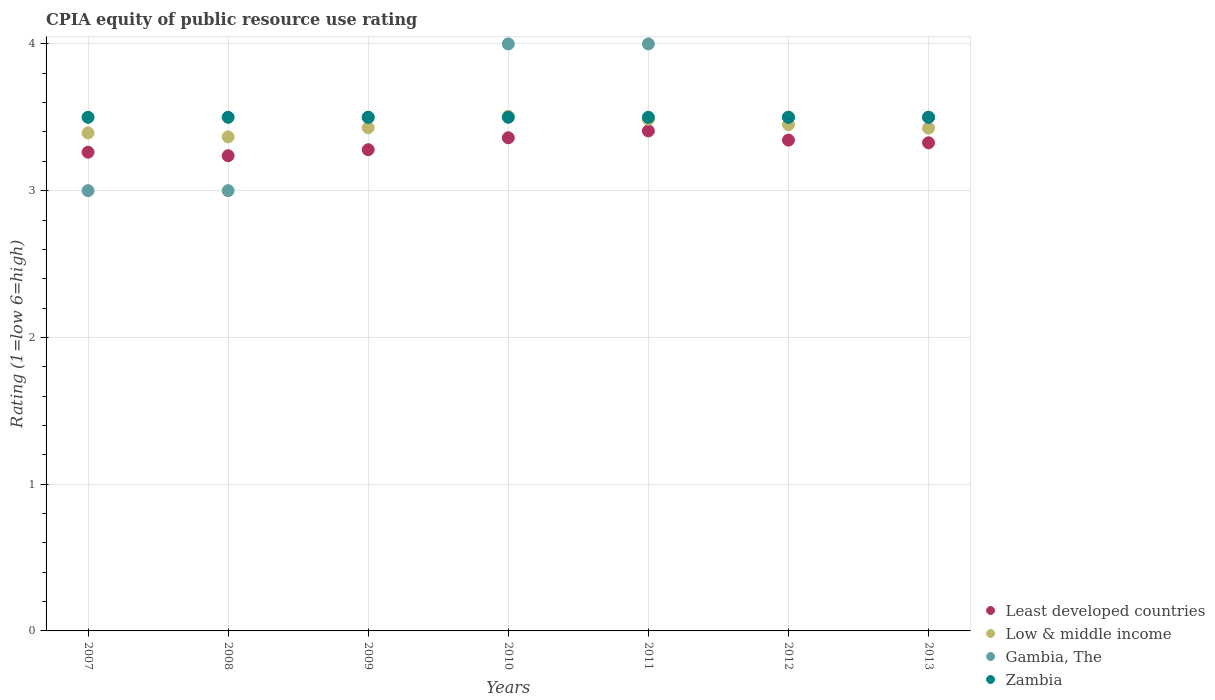How many different coloured dotlines are there?
Provide a short and direct response. 4. Across all years, what is the maximum CPIA rating in Zambia?
Offer a very short reply. 3.5. Across all years, what is the minimum CPIA rating in Zambia?
Make the answer very short. 3.5. What is the difference between the CPIA rating in Low & middle income in 2010 and that in 2012?
Your answer should be compact. 0.06. What is the difference between the CPIA rating in Zambia in 2013 and the CPIA rating in Low & middle income in 2012?
Provide a short and direct response. 0.05. What is the average CPIA rating in Least developed countries per year?
Make the answer very short. 3.32. In the year 2009, what is the difference between the CPIA rating in Zambia and CPIA rating in Low & middle income?
Your response must be concise. 0.07. In how many years, is the CPIA rating in Zambia greater than 1?
Ensure brevity in your answer.  7. What is the ratio of the CPIA rating in Zambia in 2008 to that in 2013?
Offer a terse response. 1. Is the CPIA rating in Least developed countries in 2010 less than that in 2011?
Give a very brief answer. Yes. What is the difference between the highest and the second highest CPIA rating in Low & middle income?
Your response must be concise. 0.02. In how many years, is the CPIA rating in Zambia greater than the average CPIA rating in Zambia taken over all years?
Provide a short and direct response. 0. Is the sum of the CPIA rating in Zambia in 2008 and 2011 greater than the maximum CPIA rating in Gambia, The across all years?
Give a very brief answer. Yes. Is it the case that in every year, the sum of the CPIA rating in Least developed countries and CPIA rating in Low & middle income  is greater than the sum of CPIA rating in Gambia, The and CPIA rating in Zambia?
Ensure brevity in your answer.  No. Is the CPIA rating in Low & middle income strictly greater than the CPIA rating in Least developed countries over the years?
Keep it short and to the point. Yes. How many dotlines are there?
Your answer should be compact. 4. What is the difference between two consecutive major ticks on the Y-axis?
Your response must be concise. 1. Are the values on the major ticks of Y-axis written in scientific E-notation?
Provide a succinct answer. No. Does the graph contain grids?
Offer a terse response. Yes. How many legend labels are there?
Give a very brief answer. 4. How are the legend labels stacked?
Make the answer very short. Vertical. What is the title of the graph?
Make the answer very short. CPIA equity of public resource use rating. What is the label or title of the X-axis?
Provide a succinct answer. Years. What is the Rating (1=low 6=high) in Least developed countries in 2007?
Provide a short and direct response. 3.26. What is the Rating (1=low 6=high) of Low & middle income in 2007?
Your response must be concise. 3.39. What is the Rating (1=low 6=high) of Gambia, The in 2007?
Keep it short and to the point. 3. What is the Rating (1=low 6=high) in Least developed countries in 2008?
Your answer should be compact. 3.24. What is the Rating (1=low 6=high) in Low & middle income in 2008?
Give a very brief answer. 3.37. What is the Rating (1=low 6=high) of Gambia, The in 2008?
Your answer should be very brief. 3. What is the Rating (1=low 6=high) of Zambia in 2008?
Offer a very short reply. 3.5. What is the Rating (1=low 6=high) in Least developed countries in 2009?
Your response must be concise. 3.28. What is the Rating (1=low 6=high) of Low & middle income in 2009?
Your response must be concise. 3.43. What is the Rating (1=low 6=high) in Least developed countries in 2010?
Provide a succinct answer. 3.36. What is the Rating (1=low 6=high) of Low & middle income in 2010?
Offer a terse response. 3.51. What is the Rating (1=low 6=high) of Gambia, The in 2010?
Make the answer very short. 4. What is the Rating (1=low 6=high) of Zambia in 2010?
Ensure brevity in your answer.  3.5. What is the Rating (1=low 6=high) in Least developed countries in 2011?
Offer a terse response. 3.41. What is the Rating (1=low 6=high) of Low & middle income in 2011?
Make the answer very short. 3.49. What is the Rating (1=low 6=high) of Zambia in 2011?
Provide a short and direct response. 3.5. What is the Rating (1=low 6=high) in Least developed countries in 2012?
Offer a terse response. 3.34. What is the Rating (1=low 6=high) of Low & middle income in 2012?
Offer a very short reply. 3.45. What is the Rating (1=low 6=high) of Gambia, The in 2012?
Make the answer very short. 3.5. What is the Rating (1=low 6=high) of Least developed countries in 2013?
Your answer should be compact. 3.33. What is the Rating (1=low 6=high) of Low & middle income in 2013?
Provide a short and direct response. 3.43. Across all years, what is the maximum Rating (1=low 6=high) in Least developed countries?
Provide a short and direct response. 3.41. Across all years, what is the maximum Rating (1=low 6=high) in Low & middle income?
Your answer should be very brief. 3.51. Across all years, what is the maximum Rating (1=low 6=high) in Gambia, The?
Offer a very short reply. 4. Across all years, what is the maximum Rating (1=low 6=high) of Zambia?
Your answer should be compact. 3.5. Across all years, what is the minimum Rating (1=low 6=high) of Least developed countries?
Keep it short and to the point. 3.24. Across all years, what is the minimum Rating (1=low 6=high) of Low & middle income?
Keep it short and to the point. 3.37. Across all years, what is the minimum Rating (1=low 6=high) of Gambia, The?
Make the answer very short. 3. Across all years, what is the minimum Rating (1=low 6=high) in Zambia?
Give a very brief answer. 3.5. What is the total Rating (1=low 6=high) of Least developed countries in the graph?
Ensure brevity in your answer.  23.22. What is the total Rating (1=low 6=high) of Low & middle income in the graph?
Offer a very short reply. 24.06. What is the total Rating (1=low 6=high) of Zambia in the graph?
Offer a terse response. 24.5. What is the difference between the Rating (1=low 6=high) of Least developed countries in 2007 and that in 2008?
Keep it short and to the point. 0.02. What is the difference between the Rating (1=low 6=high) of Low & middle income in 2007 and that in 2008?
Your response must be concise. 0.03. What is the difference between the Rating (1=low 6=high) in Gambia, The in 2007 and that in 2008?
Provide a succinct answer. 0. What is the difference between the Rating (1=low 6=high) of Zambia in 2007 and that in 2008?
Provide a succinct answer. 0. What is the difference between the Rating (1=low 6=high) in Least developed countries in 2007 and that in 2009?
Provide a succinct answer. -0.02. What is the difference between the Rating (1=low 6=high) in Low & middle income in 2007 and that in 2009?
Offer a very short reply. -0.04. What is the difference between the Rating (1=low 6=high) of Least developed countries in 2007 and that in 2010?
Offer a terse response. -0.1. What is the difference between the Rating (1=low 6=high) in Low & middle income in 2007 and that in 2010?
Give a very brief answer. -0.11. What is the difference between the Rating (1=low 6=high) of Least developed countries in 2007 and that in 2011?
Your response must be concise. -0.15. What is the difference between the Rating (1=low 6=high) of Low & middle income in 2007 and that in 2011?
Ensure brevity in your answer.  -0.09. What is the difference between the Rating (1=low 6=high) in Zambia in 2007 and that in 2011?
Provide a short and direct response. 0. What is the difference between the Rating (1=low 6=high) in Least developed countries in 2007 and that in 2012?
Ensure brevity in your answer.  -0.08. What is the difference between the Rating (1=low 6=high) of Low & middle income in 2007 and that in 2012?
Make the answer very short. -0.06. What is the difference between the Rating (1=low 6=high) of Gambia, The in 2007 and that in 2012?
Your response must be concise. -0.5. What is the difference between the Rating (1=low 6=high) in Zambia in 2007 and that in 2012?
Provide a succinct answer. 0. What is the difference between the Rating (1=low 6=high) of Least developed countries in 2007 and that in 2013?
Provide a short and direct response. -0.06. What is the difference between the Rating (1=low 6=high) in Low & middle income in 2007 and that in 2013?
Ensure brevity in your answer.  -0.03. What is the difference between the Rating (1=low 6=high) in Gambia, The in 2007 and that in 2013?
Keep it short and to the point. -0.5. What is the difference between the Rating (1=low 6=high) of Zambia in 2007 and that in 2013?
Give a very brief answer. 0. What is the difference between the Rating (1=low 6=high) in Least developed countries in 2008 and that in 2009?
Provide a short and direct response. -0.04. What is the difference between the Rating (1=low 6=high) in Low & middle income in 2008 and that in 2009?
Offer a very short reply. -0.06. What is the difference between the Rating (1=low 6=high) in Gambia, The in 2008 and that in 2009?
Give a very brief answer. -0.5. What is the difference between the Rating (1=low 6=high) of Least developed countries in 2008 and that in 2010?
Your answer should be compact. -0.12. What is the difference between the Rating (1=low 6=high) of Low & middle income in 2008 and that in 2010?
Give a very brief answer. -0.14. What is the difference between the Rating (1=low 6=high) in Least developed countries in 2008 and that in 2011?
Your response must be concise. -0.17. What is the difference between the Rating (1=low 6=high) in Low & middle income in 2008 and that in 2011?
Your response must be concise. -0.12. What is the difference between the Rating (1=low 6=high) of Gambia, The in 2008 and that in 2011?
Keep it short and to the point. -1. What is the difference between the Rating (1=low 6=high) in Least developed countries in 2008 and that in 2012?
Give a very brief answer. -0.11. What is the difference between the Rating (1=low 6=high) of Low & middle income in 2008 and that in 2012?
Provide a short and direct response. -0.08. What is the difference between the Rating (1=low 6=high) in Least developed countries in 2008 and that in 2013?
Offer a terse response. -0.09. What is the difference between the Rating (1=low 6=high) in Low & middle income in 2008 and that in 2013?
Your answer should be compact. -0.06. What is the difference between the Rating (1=low 6=high) of Least developed countries in 2009 and that in 2010?
Keep it short and to the point. -0.08. What is the difference between the Rating (1=low 6=high) in Low & middle income in 2009 and that in 2010?
Provide a short and direct response. -0.08. What is the difference between the Rating (1=low 6=high) in Gambia, The in 2009 and that in 2010?
Your response must be concise. -0.5. What is the difference between the Rating (1=low 6=high) in Zambia in 2009 and that in 2010?
Give a very brief answer. 0. What is the difference between the Rating (1=low 6=high) in Least developed countries in 2009 and that in 2011?
Your answer should be compact. -0.13. What is the difference between the Rating (1=low 6=high) in Low & middle income in 2009 and that in 2011?
Your answer should be compact. -0.06. What is the difference between the Rating (1=low 6=high) in Gambia, The in 2009 and that in 2011?
Your answer should be very brief. -0.5. What is the difference between the Rating (1=low 6=high) in Zambia in 2009 and that in 2011?
Offer a very short reply. 0. What is the difference between the Rating (1=low 6=high) of Least developed countries in 2009 and that in 2012?
Provide a succinct answer. -0.07. What is the difference between the Rating (1=low 6=high) of Low & middle income in 2009 and that in 2012?
Provide a succinct answer. -0.02. What is the difference between the Rating (1=low 6=high) in Least developed countries in 2009 and that in 2013?
Your response must be concise. -0.05. What is the difference between the Rating (1=low 6=high) of Low & middle income in 2009 and that in 2013?
Your response must be concise. 0. What is the difference between the Rating (1=low 6=high) of Least developed countries in 2010 and that in 2011?
Keep it short and to the point. -0.05. What is the difference between the Rating (1=low 6=high) of Low & middle income in 2010 and that in 2011?
Offer a terse response. 0.02. What is the difference between the Rating (1=low 6=high) in Least developed countries in 2010 and that in 2012?
Offer a terse response. 0.02. What is the difference between the Rating (1=low 6=high) of Low & middle income in 2010 and that in 2012?
Your response must be concise. 0.06. What is the difference between the Rating (1=low 6=high) of Zambia in 2010 and that in 2012?
Ensure brevity in your answer.  0. What is the difference between the Rating (1=low 6=high) of Least developed countries in 2010 and that in 2013?
Your response must be concise. 0.03. What is the difference between the Rating (1=low 6=high) of Low & middle income in 2010 and that in 2013?
Ensure brevity in your answer.  0.08. What is the difference between the Rating (1=low 6=high) in Least developed countries in 2011 and that in 2012?
Offer a terse response. 0.06. What is the difference between the Rating (1=low 6=high) of Low & middle income in 2011 and that in 2012?
Keep it short and to the point. 0.04. What is the difference between the Rating (1=low 6=high) of Zambia in 2011 and that in 2012?
Your answer should be compact. 0. What is the difference between the Rating (1=low 6=high) in Least developed countries in 2011 and that in 2013?
Your answer should be compact. 0.08. What is the difference between the Rating (1=low 6=high) in Low & middle income in 2011 and that in 2013?
Provide a short and direct response. 0.06. What is the difference between the Rating (1=low 6=high) of Gambia, The in 2011 and that in 2013?
Your answer should be very brief. 0.5. What is the difference between the Rating (1=low 6=high) in Zambia in 2011 and that in 2013?
Offer a terse response. 0. What is the difference between the Rating (1=low 6=high) of Least developed countries in 2012 and that in 2013?
Provide a succinct answer. 0.02. What is the difference between the Rating (1=low 6=high) in Low & middle income in 2012 and that in 2013?
Offer a terse response. 0.02. What is the difference between the Rating (1=low 6=high) of Zambia in 2012 and that in 2013?
Make the answer very short. 0. What is the difference between the Rating (1=low 6=high) of Least developed countries in 2007 and the Rating (1=low 6=high) of Low & middle income in 2008?
Provide a succinct answer. -0.1. What is the difference between the Rating (1=low 6=high) in Least developed countries in 2007 and the Rating (1=low 6=high) in Gambia, The in 2008?
Make the answer very short. 0.26. What is the difference between the Rating (1=low 6=high) of Least developed countries in 2007 and the Rating (1=low 6=high) of Zambia in 2008?
Provide a succinct answer. -0.24. What is the difference between the Rating (1=low 6=high) of Low & middle income in 2007 and the Rating (1=low 6=high) of Gambia, The in 2008?
Keep it short and to the point. 0.39. What is the difference between the Rating (1=low 6=high) of Low & middle income in 2007 and the Rating (1=low 6=high) of Zambia in 2008?
Make the answer very short. -0.11. What is the difference between the Rating (1=low 6=high) in Gambia, The in 2007 and the Rating (1=low 6=high) in Zambia in 2008?
Provide a short and direct response. -0.5. What is the difference between the Rating (1=low 6=high) in Least developed countries in 2007 and the Rating (1=low 6=high) in Low & middle income in 2009?
Your response must be concise. -0.17. What is the difference between the Rating (1=low 6=high) of Least developed countries in 2007 and the Rating (1=low 6=high) of Gambia, The in 2009?
Ensure brevity in your answer.  -0.24. What is the difference between the Rating (1=low 6=high) in Least developed countries in 2007 and the Rating (1=low 6=high) in Zambia in 2009?
Keep it short and to the point. -0.24. What is the difference between the Rating (1=low 6=high) in Low & middle income in 2007 and the Rating (1=low 6=high) in Gambia, The in 2009?
Ensure brevity in your answer.  -0.11. What is the difference between the Rating (1=low 6=high) in Low & middle income in 2007 and the Rating (1=low 6=high) in Zambia in 2009?
Keep it short and to the point. -0.11. What is the difference between the Rating (1=low 6=high) of Least developed countries in 2007 and the Rating (1=low 6=high) of Low & middle income in 2010?
Keep it short and to the point. -0.24. What is the difference between the Rating (1=low 6=high) in Least developed countries in 2007 and the Rating (1=low 6=high) in Gambia, The in 2010?
Offer a terse response. -0.74. What is the difference between the Rating (1=low 6=high) in Least developed countries in 2007 and the Rating (1=low 6=high) in Zambia in 2010?
Your response must be concise. -0.24. What is the difference between the Rating (1=low 6=high) in Low & middle income in 2007 and the Rating (1=low 6=high) in Gambia, The in 2010?
Your response must be concise. -0.61. What is the difference between the Rating (1=low 6=high) of Low & middle income in 2007 and the Rating (1=low 6=high) of Zambia in 2010?
Keep it short and to the point. -0.11. What is the difference between the Rating (1=low 6=high) in Gambia, The in 2007 and the Rating (1=low 6=high) in Zambia in 2010?
Make the answer very short. -0.5. What is the difference between the Rating (1=low 6=high) in Least developed countries in 2007 and the Rating (1=low 6=high) in Low & middle income in 2011?
Provide a succinct answer. -0.23. What is the difference between the Rating (1=low 6=high) in Least developed countries in 2007 and the Rating (1=low 6=high) in Gambia, The in 2011?
Make the answer very short. -0.74. What is the difference between the Rating (1=low 6=high) in Least developed countries in 2007 and the Rating (1=low 6=high) in Zambia in 2011?
Keep it short and to the point. -0.24. What is the difference between the Rating (1=low 6=high) in Low & middle income in 2007 and the Rating (1=low 6=high) in Gambia, The in 2011?
Give a very brief answer. -0.61. What is the difference between the Rating (1=low 6=high) of Low & middle income in 2007 and the Rating (1=low 6=high) of Zambia in 2011?
Your answer should be compact. -0.11. What is the difference between the Rating (1=low 6=high) of Least developed countries in 2007 and the Rating (1=low 6=high) of Low & middle income in 2012?
Your answer should be compact. -0.19. What is the difference between the Rating (1=low 6=high) of Least developed countries in 2007 and the Rating (1=low 6=high) of Gambia, The in 2012?
Ensure brevity in your answer.  -0.24. What is the difference between the Rating (1=low 6=high) in Least developed countries in 2007 and the Rating (1=low 6=high) in Zambia in 2012?
Ensure brevity in your answer.  -0.24. What is the difference between the Rating (1=low 6=high) of Low & middle income in 2007 and the Rating (1=low 6=high) of Gambia, The in 2012?
Ensure brevity in your answer.  -0.11. What is the difference between the Rating (1=low 6=high) of Low & middle income in 2007 and the Rating (1=low 6=high) of Zambia in 2012?
Ensure brevity in your answer.  -0.11. What is the difference between the Rating (1=low 6=high) of Gambia, The in 2007 and the Rating (1=low 6=high) of Zambia in 2012?
Your answer should be very brief. -0.5. What is the difference between the Rating (1=low 6=high) in Least developed countries in 2007 and the Rating (1=low 6=high) in Low & middle income in 2013?
Keep it short and to the point. -0.16. What is the difference between the Rating (1=low 6=high) of Least developed countries in 2007 and the Rating (1=low 6=high) of Gambia, The in 2013?
Your answer should be compact. -0.24. What is the difference between the Rating (1=low 6=high) in Least developed countries in 2007 and the Rating (1=low 6=high) in Zambia in 2013?
Your answer should be very brief. -0.24. What is the difference between the Rating (1=low 6=high) in Low & middle income in 2007 and the Rating (1=low 6=high) in Gambia, The in 2013?
Ensure brevity in your answer.  -0.11. What is the difference between the Rating (1=low 6=high) of Low & middle income in 2007 and the Rating (1=low 6=high) of Zambia in 2013?
Ensure brevity in your answer.  -0.11. What is the difference between the Rating (1=low 6=high) of Gambia, The in 2007 and the Rating (1=low 6=high) of Zambia in 2013?
Ensure brevity in your answer.  -0.5. What is the difference between the Rating (1=low 6=high) of Least developed countries in 2008 and the Rating (1=low 6=high) of Low & middle income in 2009?
Your answer should be compact. -0.19. What is the difference between the Rating (1=low 6=high) of Least developed countries in 2008 and the Rating (1=low 6=high) of Gambia, The in 2009?
Your response must be concise. -0.26. What is the difference between the Rating (1=low 6=high) in Least developed countries in 2008 and the Rating (1=low 6=high) in Zambia in 2009?
Your response must be concise. -0.26. What is the difference between the Rating (1=low 6=high) in Low & middle income in 2008 and the Rating (1=low 6=high) in Gambia, The in 2009?
Ensure brevity in your answer.  -0.13. What is the difference between the Rating (1=low 6=high) of Low & middle income in 2008 and the Rating (1=low 6=high) of Zambia in 2009?
Give a very brief answer. -0.13. What is the difference between the Rating (1=low 6=high) in Least developed countries in 2008 and the Rating (1=low 6=high) in Low & middle income in 2010?
Your answer should be compact. -0.27. What is the difference between the Rating (1=low 6=high) of Least developed countries in 2008 and the Rating (1=low 6=high) of Gambia, The in 2010?
Offer a terse response. -0.76. What is the difference between the Rating (1=low 6=high) of Least developed countries in 2008 and the Rating (1=low 6=high) of Zambia in 2010?
Keep it short and to the point. -0.26. What is the difference between the Rating (1=low 6=high) of Low & middle income in 2008 and the Rating (1=low 6=high) of Gambia, The in 2010?
Ensure brevity in your answer.  -0.63. What is the difference between the Rating (1=low 6=high) in Low & middle income in 2008 and the Rating (1=low 6=high) in Zambia in 2010?
Your answer should be compact. -0.13. What is the difference between the Rating (1=low 6=high) of Least developed countries in 2008 and the Rating (1=low 6=high) of Low & middle income in 2011?
Provide a short and direct response. -0.25. What is the difference between the Rating (1=low 6=high) in Least developed countries in 2008 and the Rating (1=low 6=high) in Gambia, The in 2011?
Provide a short and direct response. -0.76. What is the difference between the Rating (1=low 6=high) of Least developed countries in 2008 and the Rating (1=low 6=high) of Zambia in 2011?
Keep it short and to the point. -0.26. What is the difference between the Rating (1=low 6=high) in Low & middle income in 2008 and the Rating (1=low 6=high) in Gambia, The in 2011?
Give a very brief answer. -0.63. What is the difference between the Rating (1=low 6=high) of Low & middle income in 2008 and the Rating (1=low 6=high) of Zambia in 2011?
Provide a short and direct response. -0.13. What is the difference between the Rating (1=low 6=high) in Gambia, The in 2008 and the Rating (1=low 6=high) in Zambia in 2011?
Your response must be concise. -0.5. What is the difference between the Rating (1=low 6=high) in Least developed countries in 2008 and the Rating (1=low 6=high) in Low & middle income in 2012?
Provide a succinct answer. -0.21. What is the difference between the Rating (1=low 6=high) of Least developed countries in 2008 and the Rating (1=low 6=high) of Gambia, The in 2012?
Offer a terse response. -0.26. What is the difference between the Rating (1=low 6=high) in Least developed countries in 2008 and the Rating (1=low 6=high) in Zambia in 2012?
Provide a short and direct response. -0.26. What is the difference between the Rating (1=low 6=high) in Low & middle income in 2008 and the Rating (1=low 6=high) in Gambia, The in 2012?
Provide a short and direct response. -0.13. What is the difference between the Rating (1=low 6=high) of Low & middle income in 2008 and the Rating (1=low 6=high) of Zambia in 2012?
Your response must be concise. -0.13. What is the difference between the Rating (1=low 6=high) in Least developed countries in 2008 and the Rating (1=low 6=high) in Low & middle income in 2013?
Provide a succinct answer. -0.19. What is the difference between the Rating (1=low 6=high) of Least developed countries in 2008 and the Rating (1=low 6=high) of Gambia, The in 2013?
Your answer should be very brief. -0.26. What is the difference between the Rating (1=low 6=high) in Least developed countries in 2008 and the Rating (1=low 6=high) in Zambia in 2013?
Ensure brevity in your answer.  -0.26. What is the difference between the Rating (1=low 6=high) of Low & middle income in 2008 and the Rating (1=low 6=high) of Gambia, The in 2013?
Ensure brevity in your answer.  -0.13. What is the difference between the Rating (1=low 6=high) in Low & middle income in 2008 and the Rating (1=low 6=high) in Zambia in 2013?
Offer a very short reply. -0.13. What is the difference between the Rating (1=low 6=high) in Gambia, The in 2008 and the Rating (1=low 6=high) in Zambia in 2013?
Your answer should be compact. -0.5. What is the difference between the Rating (1=low 6=high) of Least developed countries in 2009 and the Rating (1=low 6=high) of Low & middle income in 2010?
Keep it short and to the point. -0.23. What is the difference between the Rating (1=low 6=high) of Least developed countries in 2009 and the Rating (1=low 6=high) of Gambia, The in 2010?
Make the answer very short. -0.72. What is the difference between the Rating (1=low 6=high) of Least developed countries in 2009 and the Rating (1=low 6=high) of Zambia in 2010?
Make the answer very short. -0.22. What is the difference between the Rating (1=low 6=high) in Low & middle income in 2009 and the Rating (1=low 6=high) in Gambia, The in 2010?
Provide a succinct answer. -0.57. What is the difference between the Rating (1=low 6=high) in Low & middle income in 2009 and the Rating (1=low 6=high) in Zambia in 2010?
Provide a succinct answer. -0.07. What is the difference between the Rating (1=low 6=high) in Least developed countries in 2009 and the Rating (1=low 6=high) in Low & middle income in 2011?
Keep it short and to the point. -0.21. What is the difference between the Rating (1=low 6=high) of Least developed countries in 2009 and the Rating (1=low 6=high) of Gambia, The in 2011?
Offer a very short reply. -0.72. What is the difference between the Rating (1=low 6=high) in Least developed countries in 2009 and the Rating (1=low 6=high) in Zambia in 2011?
Provide a short and direct response. -0.22. What is the difference between the Rating (1=low 6=high) of Low & middle income in 2009 and the Rating (1=low 6=high) of Gambia, The in 2011?
Provide a succinct answer. -0.57. What is the difference between the Rating (1=low 6=high) in Low & middle income in 2009 and the Rating (1=low 6=high) in Zambia in 2011?
Your response must be concise. -0.07. What is the difference between the Rating (1=low 6=high) of Least developed countries in 2009 and the Rating (1=low 6=high) of Low & middle income in 2012?
Provide a short and direct response. -0.17. What is the difference between the Rating (1=low 6=high) of Least developed countries in 2009 and the Rating (1=low 6=high) of Gambia, The in 2012?
Keep it short and to the point. -0.22. What is the difference between the Rating (1=low 6=high) of Least developed countries in 2009 and the Rating (1=low 6=high) of Zambia in 2012?
Your answer should be very brief. -0.22. What is the difference between the Rating (1=low 6=high) of Low & middle income in 2009 and the Rating (1=low 6=high) of Gambia, The in 2012?
Offer a very short reply. -0.07. What is the difference between the Rating (1=low 6=high) in Low & middle income in 2009 and the Rating (1=low 6=high) in Zambia in 2012?
Provide a succinct answer. -0.07. What is the difference between the Rating (1=low 6=high) in Least developed countries in 2009 and the Rating (1=low 6=high) in Low & middle income in 2013?
Provide a succinct answer. -0.15. What is the difference between the Rating (1=low 6=high) in Least developed countries in 2009 and the Rating (1=low 6=high) in Gambia, The in 2013?
Your answer should be compact. -0.22. What is the difference between the Rating (1=low 6=high) of Least developed countries in 2009 and the Rating (1=low 6=high) of Zambia in 2013?
Provide a short and direct response. -0.22. What is the difference between the Rating (1=low 6=high) in Low & middle income in 2009 and the Rating (1=low 6=high) in Gambia, The in 2013?
Provide a short and direct response. -0.07. What is the difference between the Rating (1=low 6=high) of Low & middle income in 2009 and the Rating (1=low 6=high) of Zambia in 2013?
Offer a terse response. -0.07. What is the difference between the Rating (1=low 6=high) of Gambia, The in 2009 and the Rating (1=low 6=high) of Zambia in 2013?
Make the answer very short. 0. What is the difference between the Rating (1=low 6=high) of Least developed countries in 2010 and the Rating (1=low 6=high) of Low & middle income in 2011?
Keep it short and to the point. -0.13. What is the difference between the Rating (1=low 6=high) of Least developed countries in 2010 and the Rating (1=low 6=high) of Gambia, The in 2011?
Offer a very short reply. -0.64. What is the difference between the Rating (1=low 6=high) in Least developed countries in 2010 and the Rating (1=low 6=high) in Zambia in 2011?
Make the answer very short. -0.14. What is the difference between the Rating (1=low 6=high) of Low & middle income in 2010 and the Rating (1=low 6=high) of Gambia, The in 2011?
Offer a terse response. -0.49. What is the difference between the Rating (1=low 6=high) of Low & middle income in 2010 and the Rating (1=low 6=high) of Zambia in 2011?
Offer a very short reply. 0.01. What is the difference between the Rating (1=low 6=high) in Gambia, The in 2010 and the Rating (1=low 6=high) in Zambia in 2011?
Ensure brevity in your answer.  0.5. What is the difference between the Rating (1=low 6=high) in Least developed countries in 2010 and the Rating (1=low 6=high) in Low & middle income in 2012?
Ensure brevity in your answer.  -0.09. What is the difference between the Rating (1=low 6=high) of Least developed countries in 2010 and the Rating (1=low 6=high) of Gambia, The in 2012?
Offer a terse response. -0.14. What is the difference between the Rating (1=low 6=high) of Least developed countries in 2010 and the Rating (1=low 6=high) of Zambia in 2012?
Ensure brevity in your answer.  -0.14. What is the difference between the Rating (1=low 6=high) in Low & middle income in 2010 and the Rating (1=low 6=high) in Gambia, The in 2012?
Keep it short and to the point. 0.01. What is the difference between the Rating (1=low 6=high) of Low & middle income in 2010 and the Rating (1=low 6=high) of Zambia in 2012?
Your answer should be compact. 0.01. What is the difference between the Rating (1=low 6=high) in Least developed countries in 2010 and the Rating (1=low 6=high) in Low & middle income in 2013?
Your answer should be compact. -0.07. What is the difference between the Rating (1=low 6=high) of Least developed countries in 2010 and the Rating (1=low 6=high) of Gambia, The in 2013?
Your response must be concise. -0.14. What is the difference between the Rating (1=low 6=high) of Least developed countries in 2010 and the Rating (1=low 6=high) of Zambia in 2013?
Keep it short and to the point. -0.14. What is the difference between the Rating (1=low 6=high) in Low & middle income in 2010 and the Rating (1=low 6=high) in Gambia, The in 2013?
Give a very brief answer. 0.01. What is the difference between the Rating (1=low 6=high) of Low & middle income in 2010 and the Rating (1=low 6=high) of Zambia in 2013?
Provide a succinct answer. 0.01. What is the difference between the Rating (1=low 6=high) of Least developed countries in 2011 and the Rating (1=low 6=high) of Low & middle income in 2012?
Make the answer very short. -0.04. What is the difference between the Rating (1=low 6=high) in Least developed countries in 2011 and the Rating (1=low 6=high) in Gambia, The in 2012?
Provide a short and direct response. -0.09. What is the difference between the Rating (1=low 6=high) in Least developed countries in 2011 and the Rating (1=low 6=high) in Zambia in 2012?
Provide a short and direct response. -0.09. What is the difference between the Rating (1=low 6=high) of Low & middle income in 2011 and the Rating (1=low 6=high) of Gambia, The in 2012?
Your response must be concise. -0.01. What is the difference between the Rating (1=low 6=high) in Low & middle income in 2011 and the Rating (1=low 6=high) in Zambia in 2012?
Provide a succinct answer. -0.01. What is the difference between the Rating (1=low 6=high) in Least developed countries in 2011 and the Rating (1=low 6=high) in Low & middle income in 2013?
Ensure brevity in your answer.  -0.02. What is the difference between the Rating (1=low 6=high) in Least developed countries in 2011 and the Rating (1=low 6=high) in Gambia, The in 2013?
Give a very brief answer. -0.09. What is the difference between the Rating (1=low 6=high) of Least developed countries in 2011 and the Rating (1=low 6=high) of Zambia in 2013?
Keep it short and to the point. -0.09. What is the difference between the Rating (1=low 6=high) in Low & middle income in 2011 and the Rating (1=low 6=high) in Gambia, The in 2013?
Provide a succinct answer. -0.01. What is the difference between the Rating (1=low 6=high) of Low & middle income in 2011 and the Rating (1=low 6=high) of Zambia in 2013?
Your answer should be compact. -0.01. What is the difference between the Rating (1=low 6=high) in Least developed countries in 2012 and the Rating (1=low 6=high) in Low & middle income in 2013?
Give a very brief answer. -0.08. What is the difference between the Rating (1=low 6=high) in Least developed countries in 2012 and the Rating (1=low 6=high) in Gambia, The in 2013?
Your response must be concise. -0.16. What is the difference between the Rating (1=low 6=high) of Least developed countries in 2012 and the Rating (1=low 6=high) of Zambia in 2013?
Offer a very short reply. -0.16. What is the difference between the Rating (1=low 6=high) in Gambia, The in 2012 and the Rating (1=low 6=high) in Zambia in 2013?
Give a very brief answer. 0. What is the average Rating (1=low 6=high) of Least developed countries per year?
Ensure brevity in your answer.  3.32. What is the average Rating (1=low 6=high) in Low & middle income per year?
Offer a terse response. 3.44. What is the average Rating (1=low 6=high) in Gambia, The per year?
Provide a succinct answer. 3.5. In the year 2007, what is the difference between the Rating (1=low 6=high) of Least developed countries and Rating (1=low 6=high) of Low & middle income?
Your answer should be compact. -0.13. In the year 2007, what is the difference between the Rating (1=low 6=high) in Least developed countries and Rating (1=low 6=high) in Gambia, The?
Your answer should be very brief. 0.26. In the year 2007, what is the difference between the Rating (1=low 6=high) of Least developed countries and Rating (1=low 6=high) of Zambia?
Ensure brevity in your answer.  -0.24. In the year 2007, what is the difference between the Rating (1=low 6=high) in Low & middle income and Rating (1=low 6=high) in Gambia, The?
Make the answer very short. 0.39. In the year 2007, what is the difference between the Rating (1=low 6=high) of Low & middle income and Rating (1=low 6=high) of Zambia?
Offer a terse response. -0.11. In the year 2007, what is the difference between the Rating (1=low 6=high) in Gambia, The and Rating (1=low 6=high) in Zambia?
Your response must be concise. -0.5. In the year 2008, what is the difference between the Rating (1=low 6=high) of Least developed countries and Rating (1=low 6=high) of Low & middle income?
Your answer should be compact. -0.13. In the year 2008, what is the difference between the Rating (1=low 6=high) in Least developed countries and Rating (1=low 6=high) in Gambia, The?
Offer a terse response. 0.24. In the year 2008, what is the difference between the Rating (1=low 6=high) of Least developed countries and Rating (1=low 6=high) of Zambia?
Provide a short and direct response. -0.26. In the year 2008, what is the difference between the Rating (1=low 6=high) in Low & middle income and Rating (1=low 6=high) in Gambia, The?
Offer a very short reply. 0.37. In the year 2008, what is the difference between the Rating (1=low 6=high) in Low & middle income and Rating (1=low 6=high) in Zambia?
Give a very brief answer. -0.13. In the year 2009, what is the difference between the Rating (1=low 6=high) of Least developed countries and Rating (1=low 6=high) of Low & middle income?
Your response must be concise. -0.15. In the year 2009, what is the difference between the Rating (1=low 6=high) of Least developed countries and Rating (1=low 6=high) of Gambia, The?
Provide a short and direct response. -0.22. In the year 2009, what is the difference between the Rating (1=low 6=high) in Least developed countries and Rating (1=low 6=high) in Zambia?
Ensure brevity in your answer.  -0.22. In the year 2009, what is the difference between the Rating (1=low 6=high) in Low & middle income and Rating (1=low 6=high) in Gambia, The?
Provide a succinct answer. -0.07. In the year 2009, what is the difference between the Rating (1=low 6=high) of Low & middle income and Rating (1=low 6=high) of Zambia?
Provide a succinct answer. -0.07. In the year 2010, what is the difference between the Rating (1=low 6=high) in Least developed countries and Rating (1=low 6=high) in Low & middle income?
Offer a very short reply. -0.15. In the year 2010, what is the difference between the Rating (1=low 6=high) in Least developed countries and Rating (1=low 6=high) in Gambia, The?
Give a very brief answer. -0.64. In the year 2010, what is the difference between the Rating (1=low 6=high) in Least developed countries and Rating (1=low 6=high) in Zambia?
Offer a terse response. -0.14. In the year 2010, what is the difference between the Rating (1=low 6=high) of Low & middle income and Rating (1=low 6=high) of Gambia, The?
Provide a short and direct response. -0.49. In the year 2010, what is the difference between the Rating (1=low 6=high) in Low & middle income and Rating (1=low 6=high) in Zambia?
Provide a short and direct response. 0.01. In the year 2010, what is the difference between the Rating (1=low 6=high) of Gambia, The and Rating (1=low 6=high) of Zambia?
Make the answer very short. 0.5. In the year 2011, what is the difference between the Rating (1=low 6=high) of Least developed countries and Rating (1=low 6=high) of Low & middle income?
Keep it short and to the point. -0.08. In the year 2011, what is the difference between the Rating (1=low 6=high) in Least developed countries and Rating (1=low 6=high) in Gambia, The?
Make the answer very short. -0.59. In the year 2011, what is the difference between the Rating (1=low 6=high) of Least developed countries and Rating (1=low 6=high) of Zambia?
Provide a succinct answer. -0.09. In the year 2011, what is the difference between the Rating (1=low 6=high) in Low & middle income and Rating (1=low 6=high) in Gambia, The?
Provide a succinct answer. -0.51. In the year 2011, what is the difference between the Rating (1=low 6=high) in Low & middle income and Rating (1=low 6=high) in Zambia?
Your response must be concise. -0.01. In the year 2011, what is the difference between the Rating (1=low 6=high) of Gambia, The and Rating (1=low 6=high) of Zambia?
Offer a terse response. 0.5. In the year 2012, what is the difference between the Rating (1=low 6=high) of Least developed countries and Rating (1=low 6=high) of Low & middle income?
Offer a terse response. -0.11. In the year 2012, what is the difference between the Rating (1=low 6=high) in Least developed countries and Rating (1=low 6=high) in Gambia, The?
Make the answer very short. -0.16. In the year 2012, what is the difference between the Rating (1=low 6=high) of Least developed countries and Rating (1=low 6=high) of Zambia?
Make the answer very short. -0.16. In the year 2012, what is the difference between the Rating (1=low 6=high) of Low & middle income and Rating (1=low 6=high) of Zambia?
Provide a short and direct response. -0.05. In the year 2013, what is the difference between the Rating (1=low 6=high) of Least developed countries and Rating (1=low 6=high) of Low & middle income?
Ensure brevity in your answer.  -0.1. In the year 2013, what is the difference between the Rating (1=low 6=high) of Least developed countries and Rating (1=low 6=high) of Gambia, The?
Provide a short and direct response. -0.17. In the year 2013, what is the difference between the Rating (1=low 6=high) in Least developed countries and Rating (1=low 6=high) in Zambia?
Give a very brief answer. -0.17. In the year 2013, what is the difference between the Rating (1=low 6=high) in Low & middle income and Rating (1=low 6=high) in Gambia, The?
Offer a terse response. -0.07. In the year 2013, what is the difference between the Rating (1=low 6=high) of Low & middle income and Rating (1=low 6=high) of Zambia?
Your answer should be very brief. -0.07. In the year 2013, what is the difference between the Rating (1=low 6=high) in Gambia, The and Rating (1=low 6=high) in Zambia?
Offer a terse response. 0. What is the ratio of the Rating (1=low 6=high) of Least developed countries in 2007 to that in 2008?
Your answer should be compact. 1.01. What is the ratio of the Rating (1=low 6=high) in Low & middle income in 2007 to that in 2008?
Provide a succinct answer. 1.01. What is the ratio of the Rating (1=low 6=high) in Gambia, The in 2007 to that in 2008?
Your answer should be compact. 1. What is the ratio of the Rating (1=low 6=high) of Zambia in 2007 to that in 2008?
Your answer should be compact. 1. What is the ratio of the Rating (1=low 6=high) of Gambia, The in 2007 to that in 2009?
Your answer should be very brief. 0.86. What is the ratio of the Rating (1=low 6=high) in Zambia in 2007 to that in 2009?
Your answer should be very brief. 1. What is the ratio of the Rating (1=low 6=high) of Least developed countries in 2007 to that in 2010?
Provide a succinct answer. 0.97. What is the ratio of the Rating (1=low 6=high) of Low & middle income in 2007 to that in 2010?
Ensure brevity in your answer.  0.97. What is the ratio of the Rating (1=low 6=high) of Gambia, The in 2007 to that in 2010?
Keep it short and to the point. 0.75. What is the ratio of the Rating (1=low 6=high) in Zambia in 2007 to that in 2010?
Ensure brevity in your answer.  1. What is the ratio of the Rating (1=low 6=high) in Least developed countries in 2007 to that in 2011?
Ensure brevity in your answer.  0.96. What is the ratio of the Rating (1=low 6=high) of Low & middle income in 2007 to that in 2011?
Make the answer very short. 0.97. What is the ratio of the Rating (1=low 6=high) in Zambia in 2007 to that in 2011?
Provide a short and direct response. 1. What is the ratio of the Rating (1=low 6=high) in Least developed countries in 2007 to that in 2012?
Your answer should be compact. 0.98. What is the ratio of the Rating (1=low 6=high) in Low & middle income in 2007 to that in 2012?
Provide a succinct answer. 0.98. What is the ratio of the Rating (1=low 6=high) in Least developed countries in 2007 to that in 2013?
Ensure brevity in your answer.  0.98. What is the ratio of the Rating (1=low 6=high) in Low & middle income in 2007 to that in 2013?
Your answer should be very brief. 0.99. What is the ratio of the Rating (1=low 6=high) of Gambia, The in 2007 to that in 2013?
Make the answer very short. 0.86. What is the ratio of the Rating (1=low 6=high) of Zambia in 2007 to that in 2013?
Provide a succinct answer. 1. What is the ratio of the Rating (1=low 6=high) in Least developed countries in 2008 to that in 2009?
Ensure brevity in your answer.  0.99. What is the ratio of the Rating (1=low 6=high) of Low & middle income in 2008 to that in 2009?
Ensure brevity in your answer.  0.98. What is the ratio of the Rating (1=low 6=high) of Zambia in 2008 to that in 2009?
Make the answer very short. 1. What is the ratio of the Rating (1=low 6=high) of Least developed countries in 2008 to that in 2010?
Keep it short and to the point. 0.96. What is the ratio of the Rating (1=low 6=high) in Low & middle income in 2008 to that in 2010?
Your answer should be very brief. 0.96. What is the ratio of the Rating (1=low 6=high) in Gambia, The in 2008 to that in 2010?
Offer a terse response. 0.75. What is the ratio of the Rating (1=low 6=high) of Zambia in 2008 to that in 2010?
Your answer should be compact. 1. What is the ratio of the Rating (1=low 6=high) of Least developed countries in 2008 to that in 2011?
Make the answer very short. 0.95. What is the ratio of the Rating (1=low 6=high) in Low & middle income in 2008 to that in 2011?
Your answer should be compact. 0.97. What is the ratio of the Rating (1=low 6=high) in Zambia in 2008 to that in 2011?
Give a very brief answer. 1. What is the ratio of the Rating (1=low 6=high) in Least developed countries in 2008 to that in 2012?
Make the answer very short. 0.97. What is the ratio of the Rating (1=low 6=high) of Low & middle income in 2008 to that in 2012?
Provide a succinct answer. 0.98. What is the ratio of the Rating (1=low 6=high) of Gambia, The in 2008 to that in 2012?
Ensure brevity in your answer.  0.86. What is the ratio of the Rating (1=low 6=high) in Zambia in 2008 to that in 2012?
Your answer should be compact. 1. What is the ratio of the Rating (1=low 6=high) in Least developed countries in 2008 to that in 2013?
Provide a succinct answer. 0.97. What is the ratio of the Rating (1=low 6=high) of Low & middle income in 2008 to that in 2013?
Keep it short and to the point. 0.98. What is the ratio of the Rating (1=low 6=high) of Zambia in 2008 to that in 2013?
Provide a succinct answer. 1. What is the ratio of the Rating (1=low 6=high) of Least developed countries in 2009 to that in 2010?
Provide a succinct answer. 0.98. What is the ratio of the Rating (1=low 6=high) in Low & middle income in 2009 to that in 2010?
Offer a terse response. 0.98. What is the ratio of the Rating (1=low 6=high) of Gambia, The in 2009 to that in 2010?
Make the answer very short. 0.88. What is the ratio of the Rating (1=low 6=high) in Zambia in 2009 to that in 2010?
Provide a succinct answer. 1. What is the ratio of the Rating (1=low 6=high) of Least developed countries in 2009 to that in 2011?
Your response must be concise. 0.96. What is the ratio of the Rating (1=low 6=high) in Low & middle income in 2009 to that in 2011?
Your response must be concise. 0.98. What is the ratio of the Rating (1=low 6=high) in Gambia, The in 2009 to that in 2011?
Provide a succinct answer. 0.88. What is the ratio of the Rating (1=low 6=high) of Least developed countries in 2009 to that in 2012?
Offer a terse response. 0.98. What is the ratio of the Rating (1=low 6=high) of Low & middle income in 2009 to that in 2012?
Your answer should be compact. 0.99. What is the ratio of the Rating (1=low 6=high) of Gambia, The in 2009 to that in 2012?
Provide a short and direct response. 1. What is the ratio of the Rating (1=low 6=high) in Least developed countries in 2009 to that in 2013?
Ensure brevity in your answer.  0.99. What is the ratio of the Rating (1=low 6=high) in Gambia, The in 2009 to that in 2013?
Offer a terse response. 1. What is the ratio of the Rating (1=low 6=high) in Least developed countries in 2010 to that in 2011?
Provide a short and direct response. 0.99. What is the ratio of the Rating (1=low 6=high) in Least developed countries in 2010 to that in 2012?
Provide a succinct answer. 1. What is the ratio of the Rating (1=low 6=high) in Low & middle income in 2010 to that in 2012?
Provide a short and direct response. 1.02. What is the ratio of the Rating (1=low 6=high) in Zambia in 2010 to that in 2012?
Your response must be concise. 1. What is the ratio of the Rating (1=low 6=high) of Least developed countries in 2010 to that in 2013?
Offer a very short reply. 1.01. What is the ratio of the Rating (1=low 6=high) of Low & middle income in 2010 to that in 2013?
Offer a terse response. 1.02. What is the ratio of the Rating (1=low 6=high) of Least developed countries in 2011 to that in 2012?
Keep it short and to the point. 1.02. What is the ratio of the Rating (1=low 6=high) of Low & middle income in 2011 to that in 2012?
Make the answer very short. 1.01. What is the ratio of the Rating (1=low 6=high) of Zambia in 2011 to that in 2012?
Keep it short and to the point. 1. What is the ratio of the Rating (1=low 6=high) in Least developed countries in 2011 to that in 2013?
Your response must be concise. 1.02. What is the ratio of the Rating (1=low 6=high) of Low & middle income in 2011 to that in 2013?
Your answer should be very brief. 1.02. What is the ratio of the Rating (1=low 6=high) of Gambia, The in 2011 to that in 2013?
Give a very brief answer. 1.14. What is the ratio of the Rating (1=low 6=high) of Zambia in 2011 to that in 2013?
Provide a succinct answer. 1. What is the ratio of the Rating (1=low 6=high) of Zambia in 2012 to that in 2013?
Provide a succinct answer. 1. What is the difference between the highest and the second highest Rating (1=low 6=high) of Least developed countries?
Make the answer very short. 0.05. What is the difference between the highest and the second highest Rating (1=low 6=high) in Low & middle income?
Provide a succinct answer. 0.02. What is the difference between the highest and the second highest Rating (1=low 6=high) in Gambia, The?
Ensure brevity in your answer.  0. What is the difference between the highest and the second highest Rating (1=low 6=high) in Zambia?
Ensure brevity in your answer.  0. What is the difference between the highest and the lowest Rating (1=low 6=high) of Least developed countries?
Your answer should be compact. 0.17. What is the difference between the highest and the lowest Rating (1=low 6=high) of Low & middle income?
Keep it short and to the point. 0.14. What is the difference between the highest and the lowest Rating (1=low 6=high) in Zambia?
Keep it short and to the point. 0. 